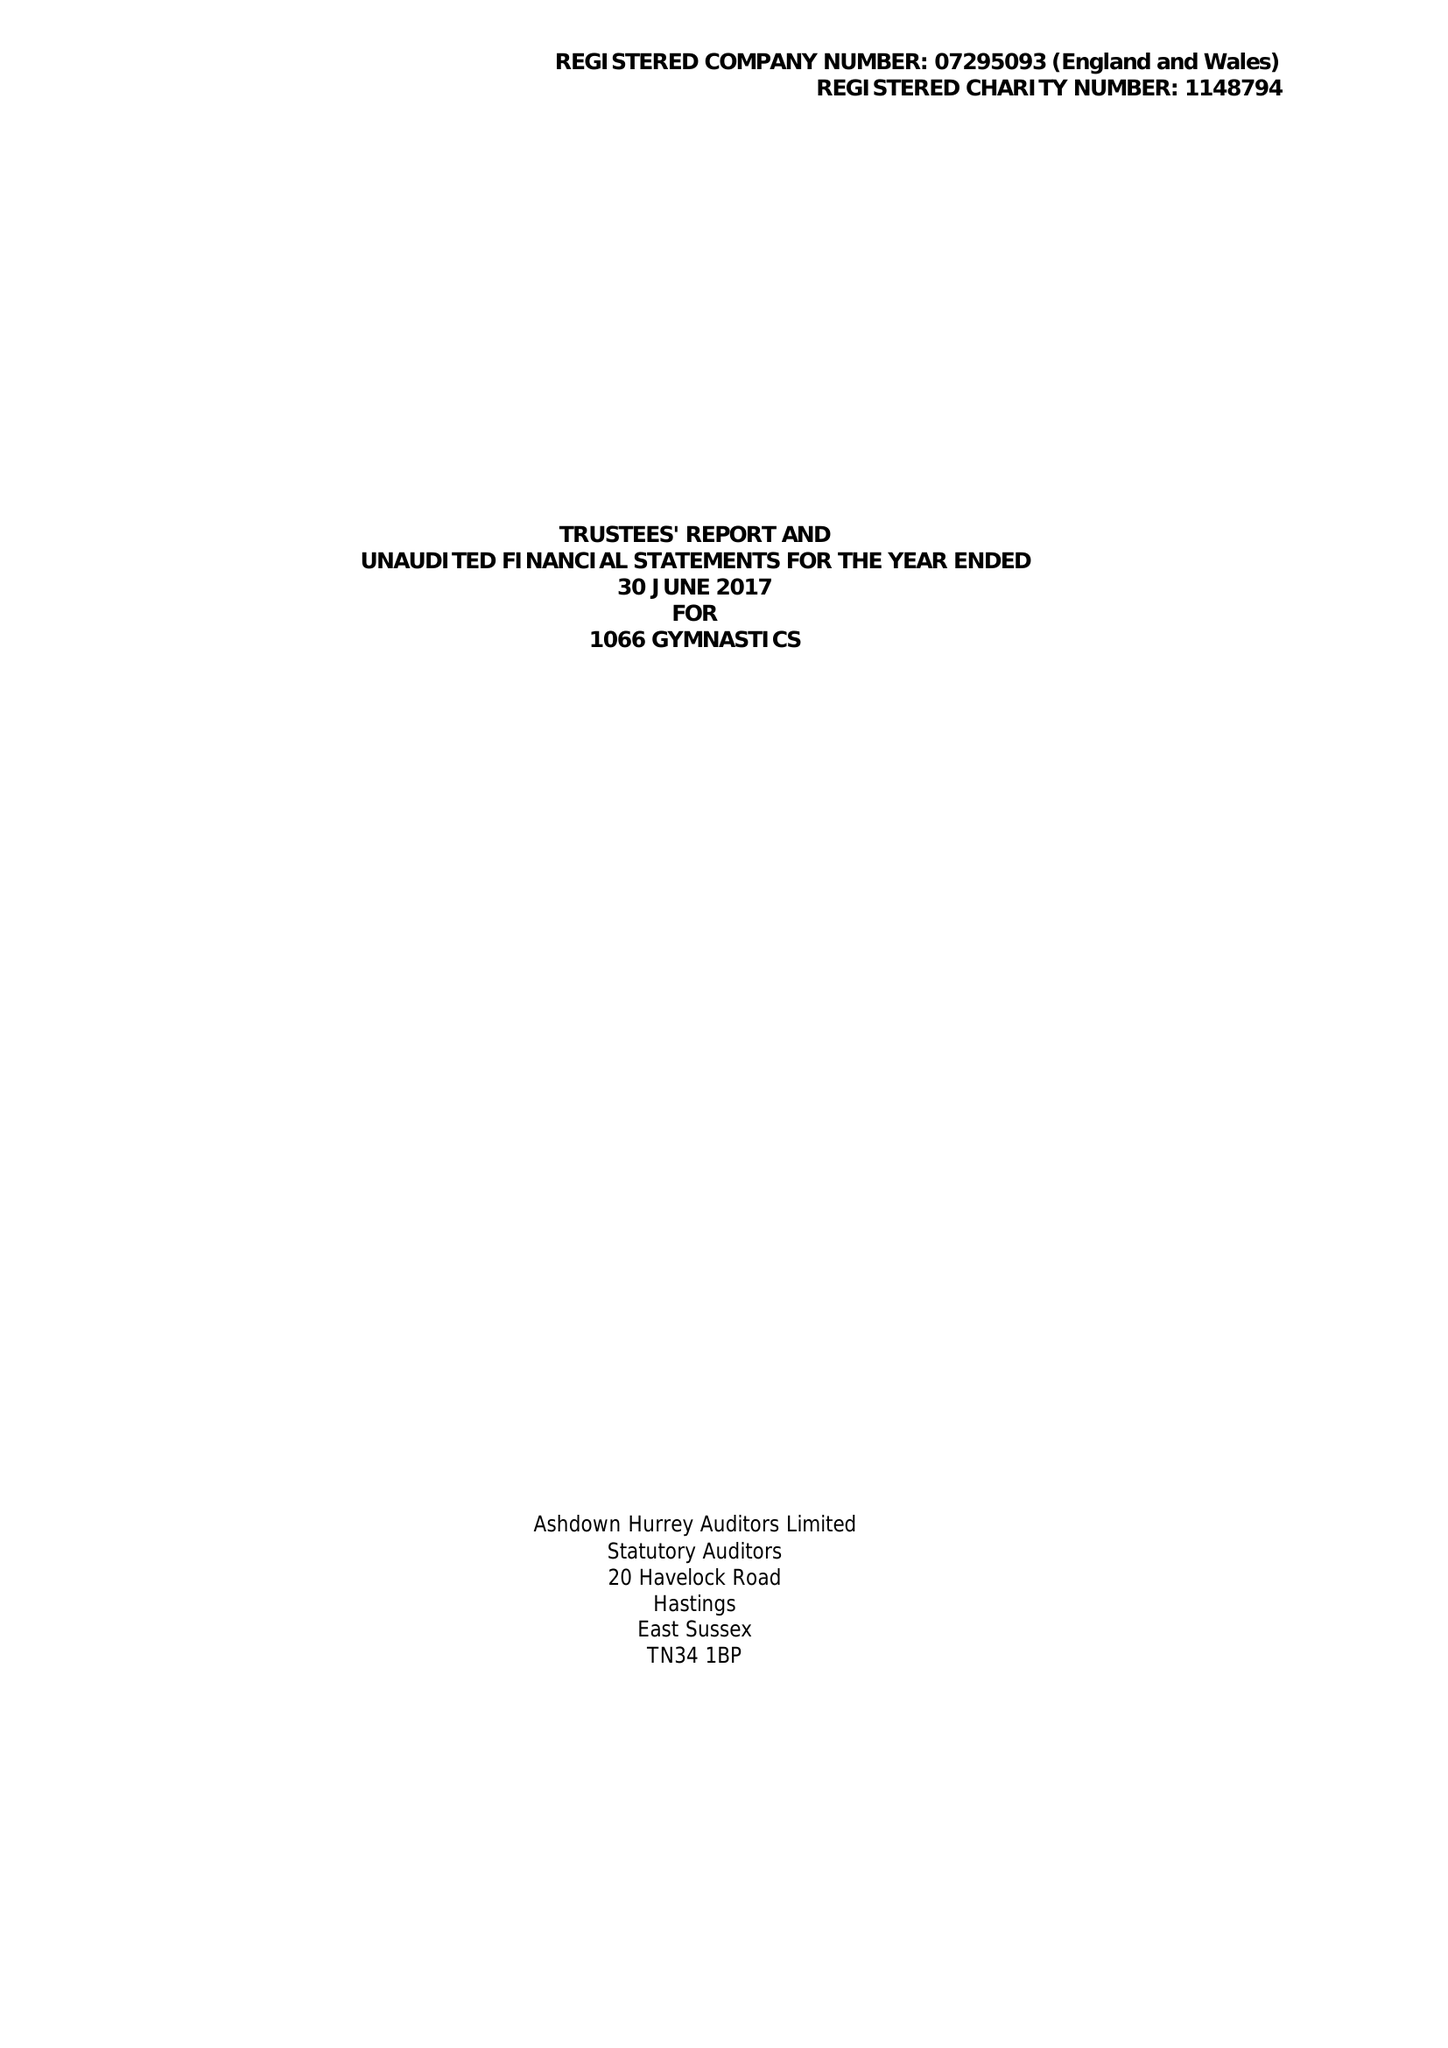What is the value for the charity_name?
Answer the question using a single word or phrase. 1066 Gymnastics 